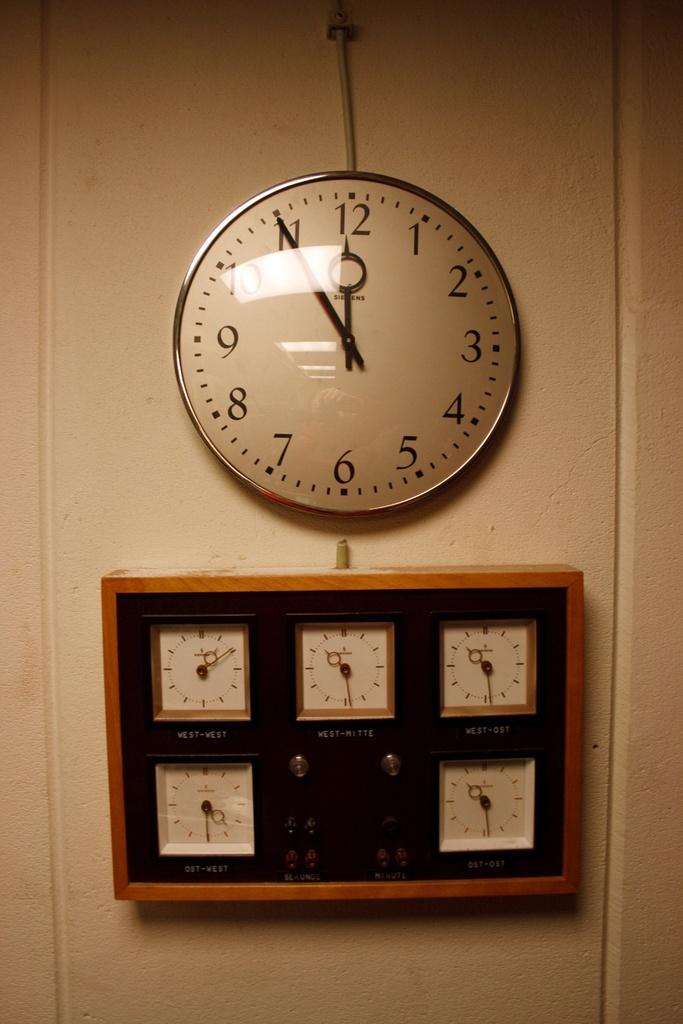Which number is the big hand pointing to?
Make the answer very short. 11. What time is it?
Provide a short and direct response. 11:55. 